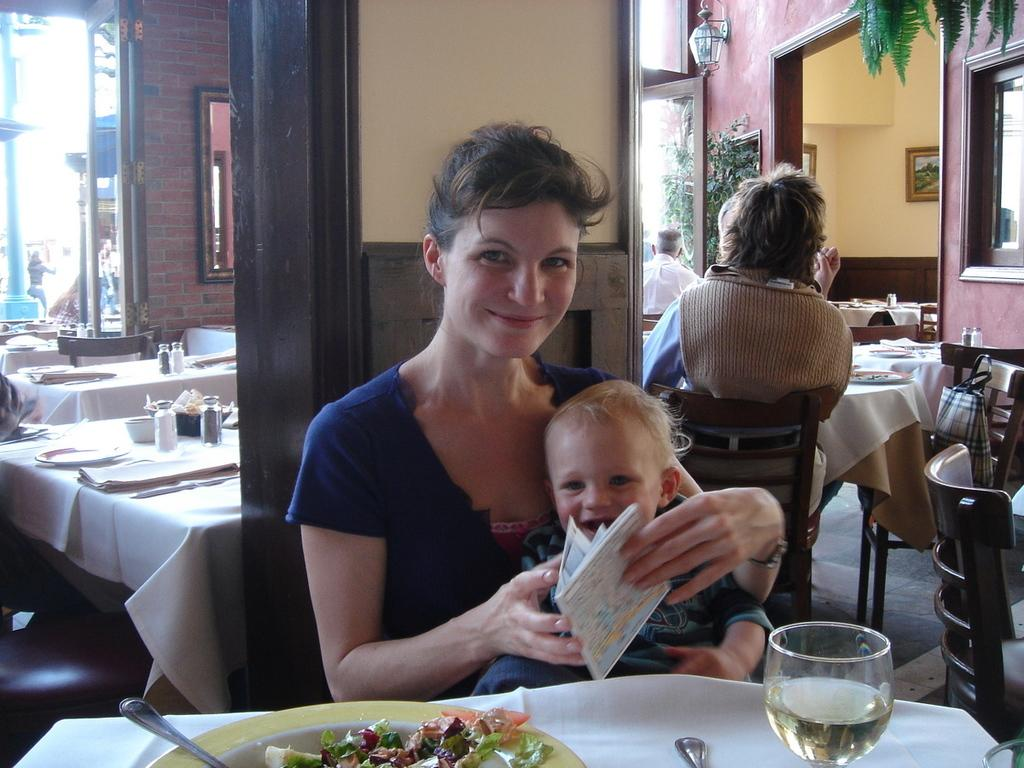Who is the main subject in the image? There is a woman in the image. What is the woman doing in the image? The woman is sitting on a chair. Is there anyone else with the woman in the image? Yes, there is a baby in the woman's lap. What can be seen in the background of the image? There are people sitting on chairs in the background. What book is the woman reading to the baby in the image? There is no book present in the image; the woman is simply holding the baby in her lap. 